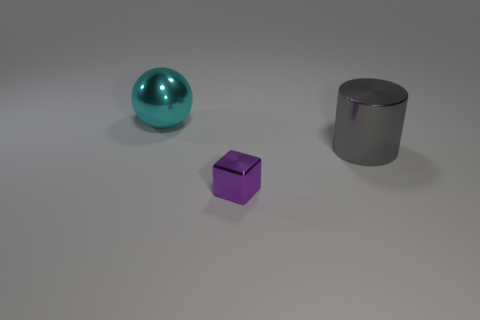What number of objects are yellow metal cylinders or things left of the gray metal cylinder? There are no yellow metal cylinders in the image, and there is one object to the left of the gray metal cylinder, which is a spherical teal object. 